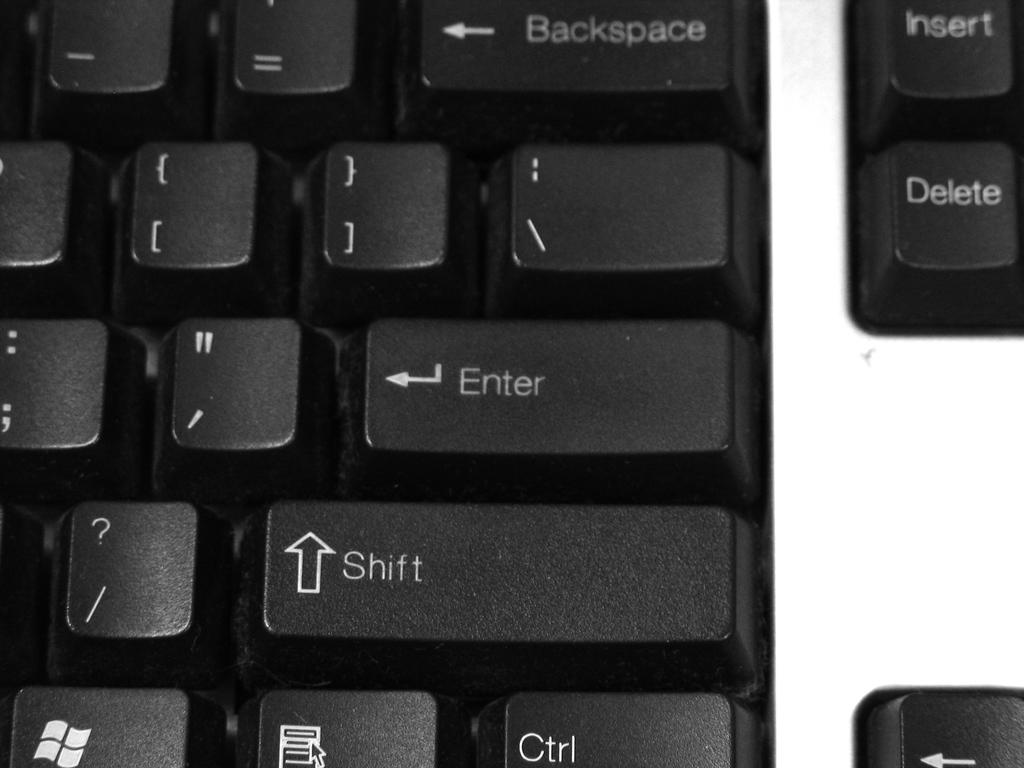<image>
Offer a succinct explanation of the picture presented. A black keyboard is shown with keys titled Enter and Shift. 